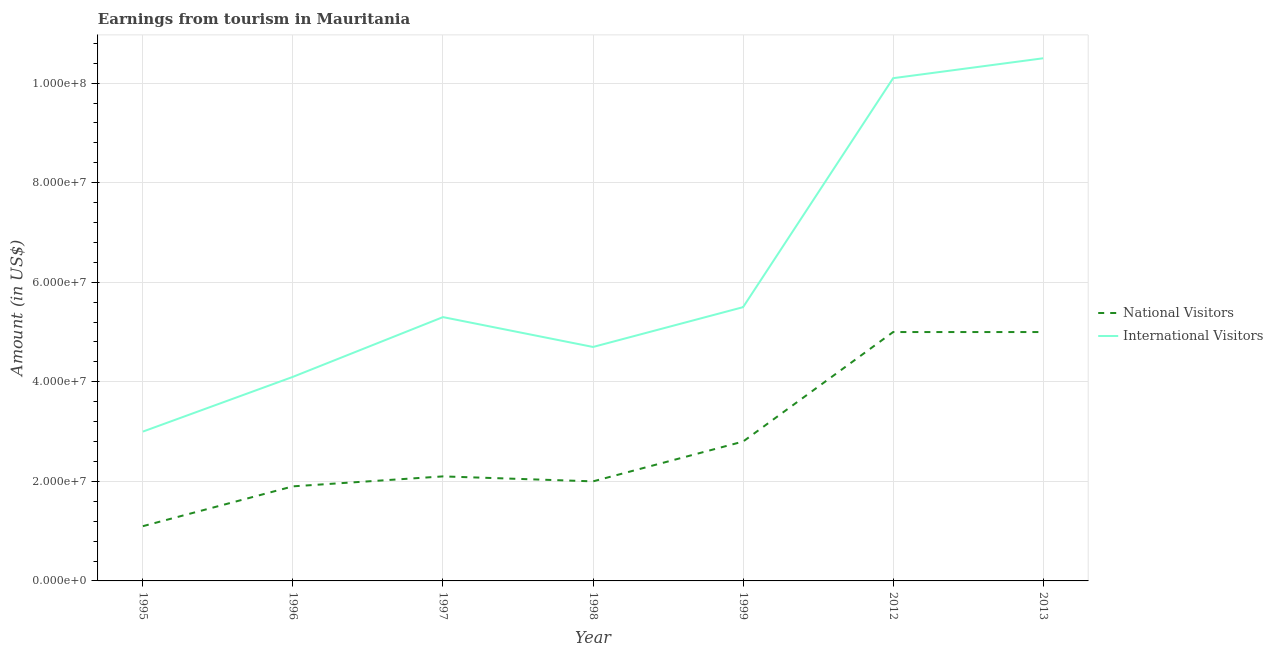Is the number of lines equal to the number of legend labels?
Make the answer very short. Yes. What is the amount earned from international visitors in 2012?
Give a very brief answer. 1.01e+08. Across all years, what is the maximum amount earned from international visitors?
Offer a terse response. 1.05e+08. Across all years, what is the minimum amount earned from international visitors?
Provide a succinct answer. 3.00e+07. In which year was the amount earned from national visitors maximum?
Provide a succinct answer. 2012. In which year was the amount earned from international visitors minimum?
Your answer should be compact. 1995. What is the total amount earned from national visitors in the graph?
Give a very brief answer. 1.99e+08. What is the difference between the amount earned from national visitors in 1996 and that in 1997?
Your answer should be very brief. -2.00e+06. What is the difference between the amount earned from national visitors in 2012 and the amount earned from international visitors in 1997?
Ensure brevity in your answer.  -3.00e+06. What is the average amount earned from national visitors per year?
Keep it short and to the point. 2.84e+07. In the year 1998, what is the difference between the amount earned from national visitors and amount earned from international visitors?
Ensure brevity in your answer.  -2.70e+07. In how many years, is the amount earned from international visitors greater than 104000000 US$?
Ensure brevity in your answer.  1. What is the ratio of the amount earned from international visitors in 1998 to that in 2013?
Make the answer very short. 0.45. What is the difference between the highest and the second highest amount earned from international visitors?
Keep it short and to the point. 4.00e+06. What is the difference between the highest and the lowest amount earned from national visitors?
Provide a succinct answer. 3.90e+07. In how many years, is the amount earned from national visitors greater than the average amount earned from national visitors taken over all years?
Your response must be concise. 2. Is the sum of the amount earned from national visitors in 1997 and 2012 greater than the maximum amount earned from international visitors across all years?
Offer a terse response. No. Does the amount earned from international visitors monotonically increase over the years?
Give a very brief answer. No. Is the amount earned from international visitors strictly less than the amount earned from national visitors over the years?
Your response must be concise. No. How many lines are there?
Your answer should be very brief. 2. What is the difference between two consecutive major ticks on the Y-axis?
Give a very brief answer. 2.00e+07. Does the graph contain any zero values?
Your answer should be compact. No. Does the graph contain grids?
Provide a short and direct response. Yes. How are the legend labels stacked?
Make the answer very short. Vertical. What is the title of the graph?
Give a very brief answer. Earnings from tourism in Mauritania. What is the label or title of the Y-axis?
Your answer should be compact. Amount (in US$). What is the Amount (in US$) in National Visitors in 1995?
Your answer should be very brief. 1.10e+07. What is the Amount (in US$) of International Visitors in 1995?
Ensure brevity in your answer.  3.00e+07. What is the Amount (in US$) in National Visitors in 1996?
Make the answer very short. 1.90e+07. What is the Amount (in US$) of International Visitors in 1996?
Offer a terse response. 4.10e+07. What is the Amount (in US$) of National Visitors in 1997?
Your answer should be very brief. 2.10e+07. What is the Amount (in US$) in International Visitors in 1997?
Give a very brief answer. 5.30e+07. What is the Amount (in US$) of International Visitors in 1998?
Keep it short and to the point. 4.70e+07. What is the Amount (in US$) in National Visitors in 1999?
Offer a terse response. 2.80e+07. What is the Amount (in US$) in International Visitors in 1999?
Provide a succinct answer. 5.50e+07. What is the Amount (in US$) in International Visitors in 2012?
Your answer should be very brief. 1.01e+08. What is the Amount (in US$) in National Visitors in 2013?
Offer a terse response. 5.00e+07. What is the Amount (in US$) of International Visitors in 2013?
Your answer should be very brief. 1.05e+08. Across all years, what is the maximum Amount (in US$) of National Visitors?
Your answer should be compact. 5.00e+07. Across all years, what is the maximum Amount (in US$) of International Visitors?
Your response must be concise. 1.05e+08. Across all years, what is the minimum Amount (in US$) in National Visitors?
Provide a short and direct response. 1.10e+07. Across all years, what is the minimum Amount (in US$) in International Visitors?
Keep it short and to the point. 3.00e+07. What is the total Amount (in US$) in National Visitors in the graph?
Make the answer very short. 1.99e+08. What is the total Amount (in US$) in International Visitors in the graph?
Your answer should be compact. 4.32e+08. What is the difference between the Amount (in US$) in National Visitors in 1995 and that in 1996?
Your answer should be compact. -8.00e+06. What is the difference between the Amount (in US$) in International Visitors in 1995 and that in 1996?
Keep it short and to the point. -1.10e+07. What is the difference between the Amount (in US$) of National Visitors in 1995 and that in 1997?
Your answer should be very brief. -1.00e+07. What is the difference between the Amount (in US$) of International Visitors in 1995 and that in 1997?
Your answer should be very brief. -2.30e+07. What is the difference between the Amount (in US$) of National Visitors in 1995 and that in 1998?
Give a very brief answer. -9.00e+06. What is the difference between the Amount (in US$) of International Visitors in 1995 and that in 1998?
Ensure brevity in your answer.  -1.70e+07. What is the difference between the Amount (in US$) of National Visitors in 1995 and that in 1999?
Provide a short and direct response. -1.70e+07. What is the difference between the Amount (in US$) in International Visitors in 1995 and that in 1999?
Provide a short and direct response. -2.50e+07. What is the difference between the Amount (in US$) of National Visitors in 1995 and that in 2012?
Provide a short and direct response. -3.90e+07. What is the difference between the Amount (in US$) in International Visitors in 1995 and that in 2012?
Make the answer very short. -7.10e+07. What is the difference between the Amount (in US$) in National Visitors in 1995 and that in 2013?
Offer a very short reply. -3.90e+07. What is the difference between the Amount (in US$) in International Visitors in 1995 and that in 2013?
Provide a short and direct response. -7.50e+07. What is the difference between the Amount (in US$) in International Visitors in 1996 and that in 1997?
Provide a short and direct response. -1.20e+07. What is the difference between the Amount (in US$) in National Visitors in 1996 and that in 1998?
Make the answer very short. -1.00e+06. What is the difference between the Amount (in US$) of International Visitors in 1996 and that in 1998?
Make the answer very short. -6.00e+06. What is the difference between the Amount (in US$) of National Visitors in 1996 and that in 1999?
Provide a succinct answer. -9.00e+06. What is the difference between the Amount (in US$) of International Visitors in 1996 and that in 1999?
Your response must be concise. -1.40e+07. What is the difference between the Amount (in US$) in National Visitors in 1996 and that in 2012?
Your response must be concise. -3.10e+07. What is the difference between the Amount (in US$) of International Visitors in 1996 and that in 2012?
Offer a terse response. -6.00e+07. What is the difference between the Amount (in US$) in National Visitors in 1996 and that in 2013?
Make the answer very short. -3.10e+07. What is the difference between the Amount (in US$) in International Visitors in 1996 and that in 2013?
Make the answer very short. -6.40e+07. What is the difference between the Amount (in US$) in National Visitors in 1997 and that in 1998?
Offer a terse response. 1.00e+06. What is the difference between the Amount (in US$) in International Visitors in 1997 and that in 1998?
Keep it short and to the point. 6.00e+06. What is the difference between the Amount (in US$) of National Visitors in 1997 and that in 1999?
Keep it short and to the point. -7.00e+06. What is the difference between the Amount (in US$) in International Visitors in 1997 and that in 1999?
Your answer should be compact. -2.00e+06. What is the difference between the Amount (in US$) of National Visitors in 1997 and that in 2012?
Offer a terse response. -2.90e+07. What is the difference between the Amount (in US$) in International Visitors in 1997 and that in 2012?
Provide a succinct answer. -4.80e+07. What is the difference between the Amount (in US$) in National Visitors in 1997 and that in 2013?
Ensure brevity in your answer.  -2.90e+07. What is the difference between the Amount (in US$) of International Visitors in 1997 and that in 2013?
Provide a short and direct response. -5.20e+07. What is the difference between the Amount (in US$) of National Visitors in 1998 and that in 1999?
Your answer should be very brief. -8.00e+06. What is the difference between the Amount (in US$) of International Visitors in 1998 and that in 1999?
Your response must be concise. -8.00e+06. What is the difference between the Amount (in US$) in National Visitors in 1998 and that in 2012?
Your answer should be compact. -3.00e+07. What is the difference between the Amount (in US$) in International Visitors in 1998 and that in 2012?
Keep it short and to the point. -5.40e+07. What is the difference between the Amount (in US$) in National Visitors in 1998 and that in 2013?
Provide a succinct answer. -3.00e+07. What is the difference between the Amount (in US$) of International Visitors in 1998 and that in 2013?
Give a very brief answer. -5.80e+07. What is the difference between the Amount (in US$) in National Visitors in 1999 and that in 2012?
Offer a very short reply. -2.20e+07. What is the difference between the Amount (in US$) of International Visitors in 1999 and that in 2012?
Offer a very short reply. -4.60e+07. What is the difference between the Amount (in US$) of National Visitors in 1999 and that in 2013?
Your answer should be very brief. -2.20e+07. What is the difference between the Amount (in US$) of International Visitors in 1999 and that in 2013?
Keep it short and to the point. -5.00e+07. What is the difference between the Amount (in US$) in National Visitors in 2012 and that in 2013?
Your answer should be compact. 0. What is the difference between the Amount (in US$) of National Visitors in 1995 and the Amount (in US$) of International Visitors in 1996?
Provide a short and direct response. -3.00e+07. What is the difference between the Amount (in US$) in National Visitors in 1995 and the Amount (in US$) in International Visitors in 1997?
Keep it short and to the point. -4.20e+07. What is the difference between the Amount (in US$) in National Visitors in 1995 and the Amount (in US$) in International Visitors in 1998?
Give a very brief answer. -3.60e+07. What is the difference between the Amount (in US$) of National Visitors in 1995 and the Amount (in US$) of International Visitors in 1999?
Make the answer very short. -4.40e+07. What is the difference between the Amount (in US$) of National Visitors in 1995 and the Amount (in US$) of International Visitors in 2012?
Make the answer very short. -9.00e+07. What is the difference between the Amount (in US$) in National Visitors in 1995 and the Amount (in US$) in International Visitors in 2013?
Make the answer very short. -9.40e+07. What is the difference between the Amount (in US$) of National Visitors in 1996 and the Amount (in US$) of International Visitors in 1997?
Your answer should be very brief. -3.40e+07. What is the difference between the Amount (in US$) of National Visitors in 1996 and the Amount (in US$) of International Visitors in 1998?
Offer a terse response. -2.80e+07. What is the difference between the Amount (in US$) of National Visitors in 1996 and the Amount (in US$) of International Visitors in 1999?
Give a very brief answer. -3.60e+07. What is the difference between the Amount (in US$) of National Visitors in 1996 and the Amount (in US$) of International Visitors in 2012?
Make the answer very short. -8.20e+07. What is the difference between the Amount (in US$) of National Visitors in 1996 and the Amount (in US$) of International Visitors in 2013?
Your response must be concise. -8.60e+07. What is the difference between the Amount (in US$) of National Visitors in 1997 and the Amount (in US$) of International Visitors in 1998?
Give a very brief answer. -2.60e+07. What is the difference between the Amount (in US$) of National Visitors in 1997 and the Amount (in US$) of International Visitors in 1999?
Provide a succinct answer. -3.40e+07. What is the difference between the Amount (in US$) in National Visitors in 1997 and the Amount (in US$) in International Visitors in 2012?
Provide a succinct answer. -8.00e+07. What is the difference between the Amount (in US$) of National Visitors in 1997 and the Amount (in US$) of International Visitors in 2013?
Offer a terse response. -8.40e+07. What is the difference between the Amount (in US$) in National Visitors in 1998 and the Amount (in US$) in International Visitors in 1999?
Your response must be concise. -3.50e+07. What is the difference between the Amount (in US$) in National Visitors in 1998 and the Amount (in US$) in International Visitors in 2012?
Keep it short and to the point. -8.10e+07. What is the difference between the Amount (in US$) in National Visitors in 1998 and the Amount (in US$) in International Visitors in 2013?
Provide a succinct answer. -8.50e+07. What is the difference between the Amount (in US$) in National Visitors in 1999 and the Amount (in US$) in International Visitors in 2012?
Ensure brevity in your answer.  -7.30e+07. What is the difference between the Amount (in US$) in National Visitors in 1999 and the Amount (in US$) in International Visitors in 2013?
Make the answer very short. -7.70e+07. What is the difference between the Amount (in US$) in National Visitors in 2012 and the Amount (in US$) in International Visitors in 2013?
Your answer should be compact. -5.50e+07. What is the average Amount (in US$) in National Visitors per year?
Offer a very short reply. 2.84e+07. What is the average Amount (in US$) in International Visitors per year?
Offer a terse response. 6.17e+07. In the year 1995, what is the difference between the Amount (in US$) in National Visitors and Amount (in US$) in International Visitors?
Your answer should be compact. -1.90e+07. In the year 1996, what is the difference between the Amount (in US$) in National Visitors and Amount (in US$) in International Visitors?
Your answer should be compact. -2.20e+07. In the year 1997, what is the difference between the Amount (in US$) in National Visitors and Amount (in US$) in International Visitors?
Your answer should be very brief. -3.20e+07. In the year 1998, what is the difference between the Amount (in US$) of National Visitors and Amount (in US$) of International Visitors?
Your answer should be very brief. -2.70e+07. In the year 1999, what is the difference between the Amount (in US$) of National Visitors and Amount (in US$) of International Visitors?
Offer a terse response. -2.70e+07. In the year 2012, what is the difference between the Amount (in US$) of National Visitors and Amount (in US$) of International Visitors?
Offer a very short reply. -5.10e+07. In the year 2013, what is the difference between the Amount (in US$) of National Visitors and Amount (in US$) of International Visitors?
Provide a short and direct response. -5.50e+07. What is the ratio of the Amount (in US$) in National Visitors in 1995 to that in 1996?
Provide a short and direct response. 0.58. What is the ratio of the Amount (in US$) of International Visitors in 1995 to that in 1996?
Provide a short and direct response. 0.73. What is the ratio of the Amount (in US$) in National Visitors in 1995 to that in 1997?
Your answer should be compact. 0.52. What is the ratio of the Amount (in US$) in International Visitors in 1995 to that in 1997?
Offer a terse response. 0.57. What is the ratio of the Amount (in US$) in National Visitors in 1995 to that in 1998?
Your response must be concise. 0.55. What is the ratio of the Amount (in US$) in International Visitors in 1995 to that in 1998?
Your answer should be compact. 0.64. What is the ratio of the Amount (in US$) of National Visitors in 1995 to that in 1999?
Offer a terse response. 0.39. What is the ratio of the Amount (in US$) in International Visitors in 1995 to that in 1999?
Ensure brevity in your answer.  0.55. What is the ratio of the Amount (in US$) in National Visitors in 1995 to that in 2012?
Provide a succinct answer. 0.22. What is the ratio of the Amount (in US$) of International Visitors in 1995 to that in 2012?
Your response must be concise. 0.3. What is the ratio of the Amount (in US$) in National Visitors in 1995 to that in 2013?
Keep it short and to the point. 0.22. What is the ratio of the Amount (in US$) of International Visitors in 1995 to that in 2013?
Make the answer very short. 0.29. What is the ratio of the Amount (in US$) of National Visitors in 1996 to that in 1997?
Your answer should be very brief. 0.9. What is the ratio of the Amount (in US$) of International Visitors in 1996 to that in 1997?
Provide a short and direct response. 0.77. What is the ratio of the Amount (in US$) of International Visitors in 1996 to that in 1998?
Keep it short and to the point. 0.87. What is the ratio of the Amount (in US$) in National Visitors in 1996 to that in 1999?
Offer a very short reply. 0.68. What is the ratio of the Amount (in US$) of International Visitors in 1996 to that in 1999?
Make the answer very short. 0.75. What is the ratio of the Amount (in US$) in National Visitors in 1996 to that in 2012?
Keep it short and to the point. 0.38. What is the ratio of the Amount (in US$) in International Visitors in 1996 to that in 2012?
Offer a terse response. 0.41. What is the ratio of the Amount (in US$) in National Visitors in 1996 to that in 2013?
Your answer should be compact. 0.38. What is the ratio of the Amount (in US$) in International Visitors in 1996 to that in 2013?
Provide a short and direct response. 0.39. What is the ratio of the Amount (in US$) of National Visitors in 1997 to that in 1998?
Offer a terse response. 1.05. What is the ratio of the Amount (in US$) in International Visitors in 1997 to that in 1998?
Make the answer very short. 1.13. What is the ratio of the Amount (in US$) in National Visitors in 1997 to that in 1999?
Make the answer very short. 0.75. What is the ratio of the Amount (in US$) of International Visitors in 1997 to that in 1999?
Your answer should be compact. 0.96. What is the ratio of the Amount (in US$) in National Visitors in 1997 to that in 2012?
Provide a succinct answer. 0.42. What is the ratio of the Amount (in US$) of International Visitors in 1997 to that in 2012?
Keep it short and to the point. 0.52. What is the ratio of the Amount (in US$) in National Visitors in 1997 to that in 2013?
Provide a short and direct response. 0.42. What is the ratio of the Amount (in US$) in International Visitors in 1997 to that in 2013?
Offer a terse response. 0.5. What is the ratio of the Amount (in US$) in National Visitors in 1998 to that in 1999?
Provide a succinct answer. 0.71. What is the ratio of the Amount (in US$) in International Visitors in 1998 to that in 1999?
Keep it short and to the point. 0.85. What is the ratio of the Amount (in US$) in National Visitors in 1998 to that in 2012?
Offer a very short reply. 0.4. What is the ratio of the Amount (in US$) of International Visitors in 1998 to that in 2012?
Provide a short and direct response. 0.47. What is the ratio of the Amount (in US$) of International Visitors in 1998 to that in 2013?
Your answer should be very brief. 0.45. What is the ratio of the Amount (in US$) in National Visitors in 1999 to that in 2012?
Offer a terse response. 0.56. What is the ratio of the Amount (in US$) in International Visitors in 1999 to that in 2012?
Offer a terse response. 0.54. What is the ratio of the Amount (in US$) of National Visitors in 1999 to that in 2013?
Your answer should be very brief. 0.56. What is the ratio of the Amount (in US$) of International Visitors in 1999 to that in 2013?
Your answer should be compact. 0.52. What is the ratio of the Amount (in US$) of International Visitors in 2012 to that in 2013?
Your response must be concise. 0.96. What is the difference between the highest and the second highest Amount (in US$) in International Visitors?
Make the answer very short. 4.00e+06. What is the difference between the highest and the lowest Amount (in US$) in National Visitors?
Give a very brief answer. 3.90e+07. What is the difference between the highest and the lowest Amount (in US$) in International Visitors?
Keep it short and to the point. 7.50e+07. 